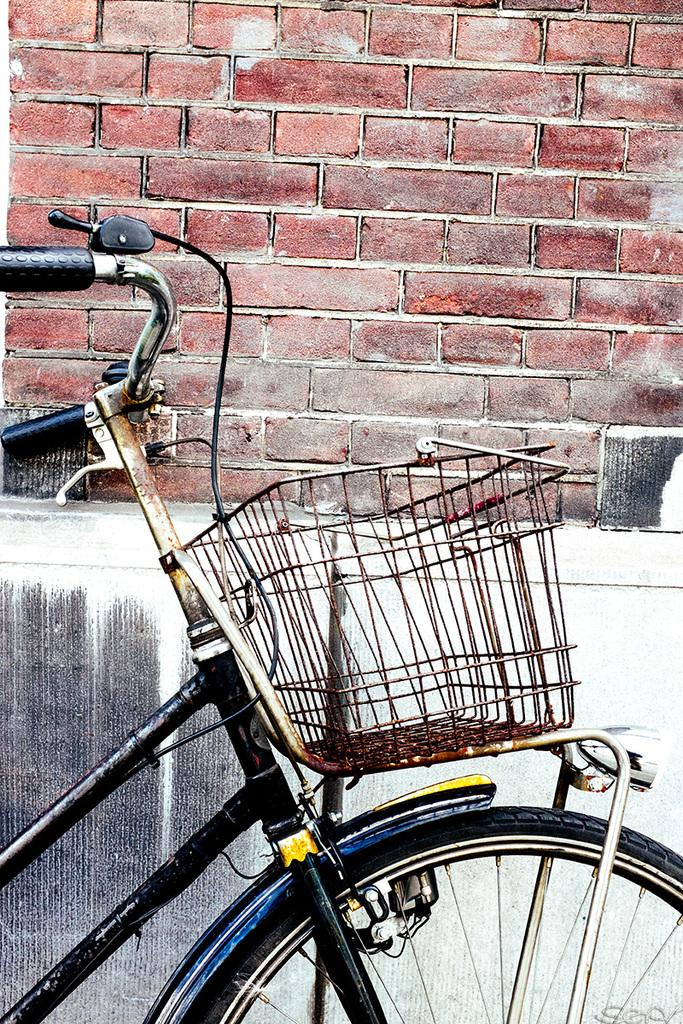What is the main object in the picture? There is a bicycle in the picture. What feature is attached to the bicycle? The bicycle has a basket attached to it. What type of structure can be seen in the background? There is a brick wall in the picture. Where is the crate located in the picture? There is no crate present in the image. What type of drum can be seen in the picture? There is no drum present in the image. 